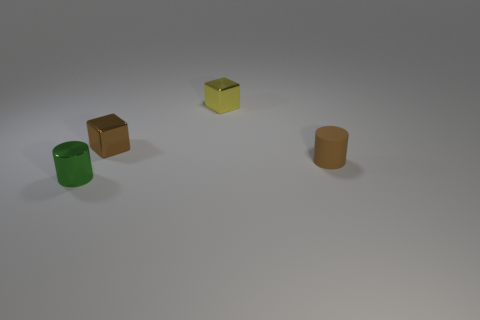The other object that is the same color as the small matte thing is what shape?
Provide a succinct answer. Cube. The cylinder behind the green thing that is on the left side of the yellow metal block is what color?
Your answer should be compact. Brown. There is another thing that is the same shape as the brown rubber thing; what is its color?
Ensure brevity in your answer.  Green. Are there any other things that have the same material as the tiny brown cylinder?
Provide a short and direct response. No. What size is the other metal object that is the same shape as the tiny yellow thing?
Keep it short and to the point. Small. There is a small block that is in front of the tiny yellow block; what is its material?
Ensure brevity in your answer.  Metal. Is the number of tiny brown metallic objects in front of the rubber cylinder less than the number of yellow objects?
Provide a succinct answer. Yes. There is a metallic object that is right of the small brown thing that is on the left side of the small yellow metal block; what is its shape?
Your answer should be very brief. Cube. The tiny metal cylinder is what color?
Your answer should be very brief. Green. How many other things are there of the same size as the yellow metallic block?
Keep it short and to the point. 3. 